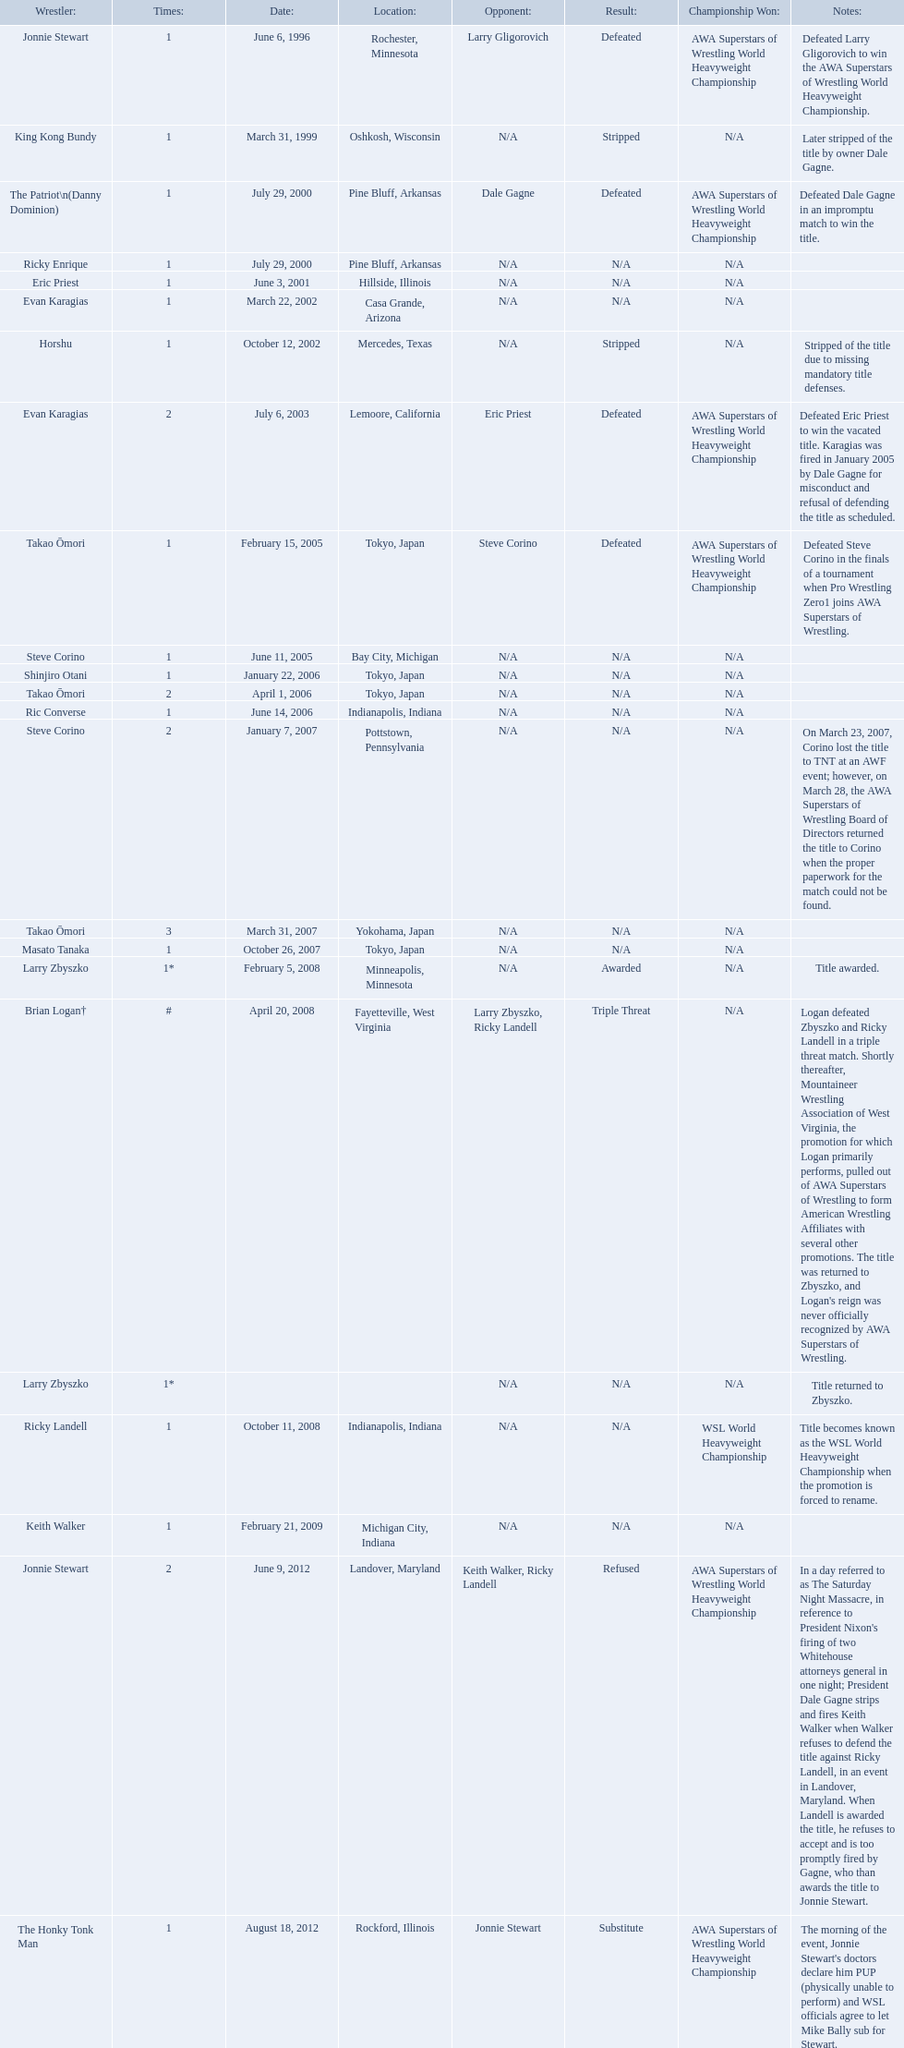Who are the wrestlers? Jonnie Stewart, Rochester, Minnesota, King Kong Bundy, Oshkosh, Wisconsin, The Patriot\n(Danny Dominion), Pine Bluff, Arkansas, Ricky Enrique, Pine Bluff, Arkansas, Eric Priest, Hillside, Illinois, Evan Karagias, Casa Grande, Arizona, Horshu, Mercedes, Texas, Evan Karagias, Lemoore, California, Takao Ōmori, Tokyo, Japan, Steve Corino, Bay City, Michigan, Shinjiro Otani, Tokyo, Japan, Takao Ōmori, Tokyo, Japan, Ric Converse, Indianapolis, Indiana, Steve Corino, Pottstown, Pennsylvania, Takao Ōmori, Yokohama, Japan, Masato Tanaka, Tokyo, Japan, Larry Zbyszko, Minneapolis, Minnesota, Brian Logan†, Fayetteville, West Virginia, Larry Zbyszko, , Ricky Landell, Indianapolis, Indiana, Keith Walker, Michigan City, Indiana, Jonnie Stewart, Landover, Maryland, The Honky Tonk Man, Rockford, Illinois. Who was from texas? Horshu, Mercedes, Texas. Who is he? Horshu. Who are all of the wrestlers? Jonnie Stewart, King Kong Bundy, The Patriot\n(Danny Dominion), Ricky Enrique, Eric Priest, Evan Karagias, Horshu, Evan Karagias, Takao Ōmori, Steve Corino, Shinjiro Otani, Takao Ōmori, Ric Converse, Steve Corino, Takao Ōmori, Masato Tanaka, Larry Zbyszko, Brian Logan†, Larry Zbyszko, Ricky Landell, Keith Walker, Jonnie Stewart, The Honky Tonk Man. Parse the table in full. {'header': ['Wrestler:', 'Times:', 'Date:', 'Location:', 'Opponent:', 'Result:', 'Championship Won:', 'Notes:'], 'rows': [['Jonnie Stewart', '1', 'June 6, 1996', 'Rochester, Minnesota', 'Larry Gligorovich', 'Defeated', 'AWA Superstars of Wrestling World Heavyweight Championship', 'Defeated Larry Gligorovich to win the AWA Superstars of Wrestling World Heavyweight Championship.'], ['King Kong Bundy', '1', 'March 31, 1999', 'Oshkosh, Wisconsin', 'N/A', 'Stripped', 'N/A', 'Later stripped of the title by owner Dale Gagne.'], ['The Patriot\\n(Danny Dominion)', '1', 'July 29, 2000', 'Pine Bluff, Arkansas', 'Dale Gagne', 'Defeated', 'AWA Superstars of Wrestling World Heavyweight Championship', 'Defeated Dale Gagne in an impromptu match to win the title.'], ['Ricky Enrique', '1', 'July 29, 2000', 'Pine Bluff, Arkansas', 'N/A', 'N/A', 'N/A', ''], ['Eric Priest', '1', 'June 3, 2001', 'Hillside, Illinois', 'N/A', 'N/A', 'N/A', ''], ['Evan Karagias', '1', 'March 22, 2002', 'Casa Grande, Arizona', 'N/A', 'N/A', 'N/A', ''], ['Horshu', '1', 'October 12, 2002', 'Mercedes, Texas', 'N/A', 'Stripped', 'N/A', 'Stripped of the title due to missing mandatory title defenses.'], ['Evan Karagias', '2', 'July 6, 2003', 'Lemoore, California', 'Eric Priest', 'Defeated', 'AWA Superstars of Wrestling World Heavyweight Championship', 'Defeated Eric Priest to win the vacated title. Karagias was fired in January 2005 by Dale Gagne for misconduct and refusal of defending the title as scheduled.'], ['Takao Ōmori', '1', 'February 15, 2005', 'Tokyo, Japan', 'Steve Corino', 'Defeated', 'AWA Superstars of Wrestling World Heavyweight Championship', 'Defeated Steve Corino in the finals of a tournament when Pro Wrestling Zero1 joins AWA Superstars of Wrestling.'], ['Steve Corino', '1', 'June 11, 2005', 'Bay City, Michigan', 'N/A', 'N/A', 'N/A', ''], ['Shinjiro Otani', '1', 'January 22, 2006', 'Tokyo, Japan', 'N/A', 'N/A', 'N/A', ''], ['Takao Ōmori', '2', 'April 1, 2006', 'Tokyo, Japan', 'N/A', 'N/A', 'N/A', ''], ['Ric Converse', '1', 'June 14, 2006', 'Indianapolis, Indiana', 'N/A', 'N/A', 'N/A', ''], ['Steve Corino', '2', 'January 7, 2007', 'Pottstown, Pennsylvania', 'N/A', 'N/A', 'N/A', 'On March 23, 2007, Corino lost the title to TNT at an AWF event; however, on March 28, the AWA Superstars of Wrestling Board of Directors returned the title to Corino when the proper paperwork for the match could not be found.'], ['Takao Ōmori', '3', 'March 31, 2007', 'Yokohama, Japan', 'N/A', 'N/A', 'N/A', ''], ['Masato Tanaka', '1', 'October 26, 2007', 'Tokyo, Japan', 'N/A', 'N/A', 'N/A', ''], ['Larry Zbyszko', '1*', 'February 5, 2008', 'Minneapolis, Minnesota', 'N/A', 'Awarded', 'N/A', 'Title awarded.'], ['Brian Logan†', '#', 'April 20, 2008', 'Fayetteville, West Virginia', 'Larry Zbyszko, Ricky Landell', 'Triple Threat', 'N/A', "Logan defeated Zbyszko and Ricky Landell in a triple threat match. Shortly thereafter, Mountaineer Wrestling Association of West Virginia, the promotion for which Logan primarily performs, pulled out of AWA Superstars of Wrestling to form American Wrestling Affiliates with several other promotions. The title was returned to Zbyszko, and Logan's reign was never officially recognized by AWA Superstars of Wrestling."], ['Larry Zbyszko', '1*', '', '', 'N/A', 'N/A', 'N/A', 'Title returned to Zbyszko.'], ['Ricky Landell', '1', 'October 11, 2008', 'Indianapolis, Indiana', 'N/A', 'N/A', 'WSL World Heavyweight Championship', 'Title becomes known as the WSL World Heavyweight Championship when the promotion is forced to rename.'], ['Keith Walker', '1', 'February 21, 2009', 'Michigan City, Indiana', 'N/A', 'N/A', 'N/A', ''], ['Jonnie Stewart', '2', 'June 9, 2012', 'Landover, Maryland', 'Keith Walker, Ricky Landell', 'Refused', 'AWA Superstars of Wrestling World Heavyweight Championship', "In a day referred to as The Saturday Night Massacre, in reference to President Nixon's firing of two Whitehouse attorneys general in one night; President Dale Gagne strips and fires Keith Walker when Walker refuses to defend the title against Ricky Landell, in an event in Landover, Maryland. When Landell is awarded the title, he refuses to accept and is too promptly fired by Gagne, who than awards the title to Jonnie Stewart."], ['The Honky Tonk Man', '1', 'August 18, 2012', 'Rockford, Illinois', 'Jonnie Stewart', 'Substitute', 'AWA Superstars of Wrestling World Heavyweight Championship', "The morning of the event, Jonnie Stewart's doctors declare him PUP (physically unable to perform) and WSL officials agree to let Mike Bally sub for Stewart."]]} Where are they from? Rochester, Minnesota, Oshkosh, Wisconsin, Pine Bluff, Arkansas, Pine Bluff, Arkansas, Hillside, Illinois, Casa Grande, Arizona, Mercedes, Texas, Lemoore, California, Tokyo, Japan, Bay City, Michigan, Tokyo, Japan, Tokyo, Japan, Indianapolis, Indiana, Pottstown, Pennsylvania, Yokohama, Japan, Tokyo, Japan, Minneapolis, Minnesota, Fayetteville, West Virginia, , Indianapolis, Indiana, Michigan City, Indiana, Landover, Maryland, Rockford, Illinois. And which of them is from texas? Horshu. Where are the title holders from? Rochester, Minnesota, Oshkosh, Wisconsin, Pine Bluff, Arkansas, Pine Bluff, Arkansas, Hillside, Illinois, Casa Grande, Arizona, Mercedes, Texas, Lemoore, California, Tokyo, Japan, Bay City, Michigan, Tokyo, Japan, Tokyo, Japan, Indianapolis, Indiana, Pottstown, Pennsylvania, Yokohama, Japan, Tokyo, Japan, Minneapolis, Minnesota, Fayetteville, West Virginia, , Indianapolis, Indiana, Michigan City, Indiana, Landover, Maryland, Rockford, Illinois. Who is the title holder from texas? Horshu. 